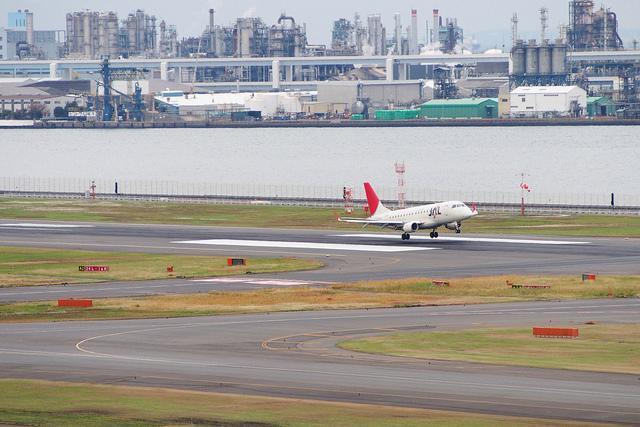How many people are wearing yellow vests?
Give a very brief answer. 0. 